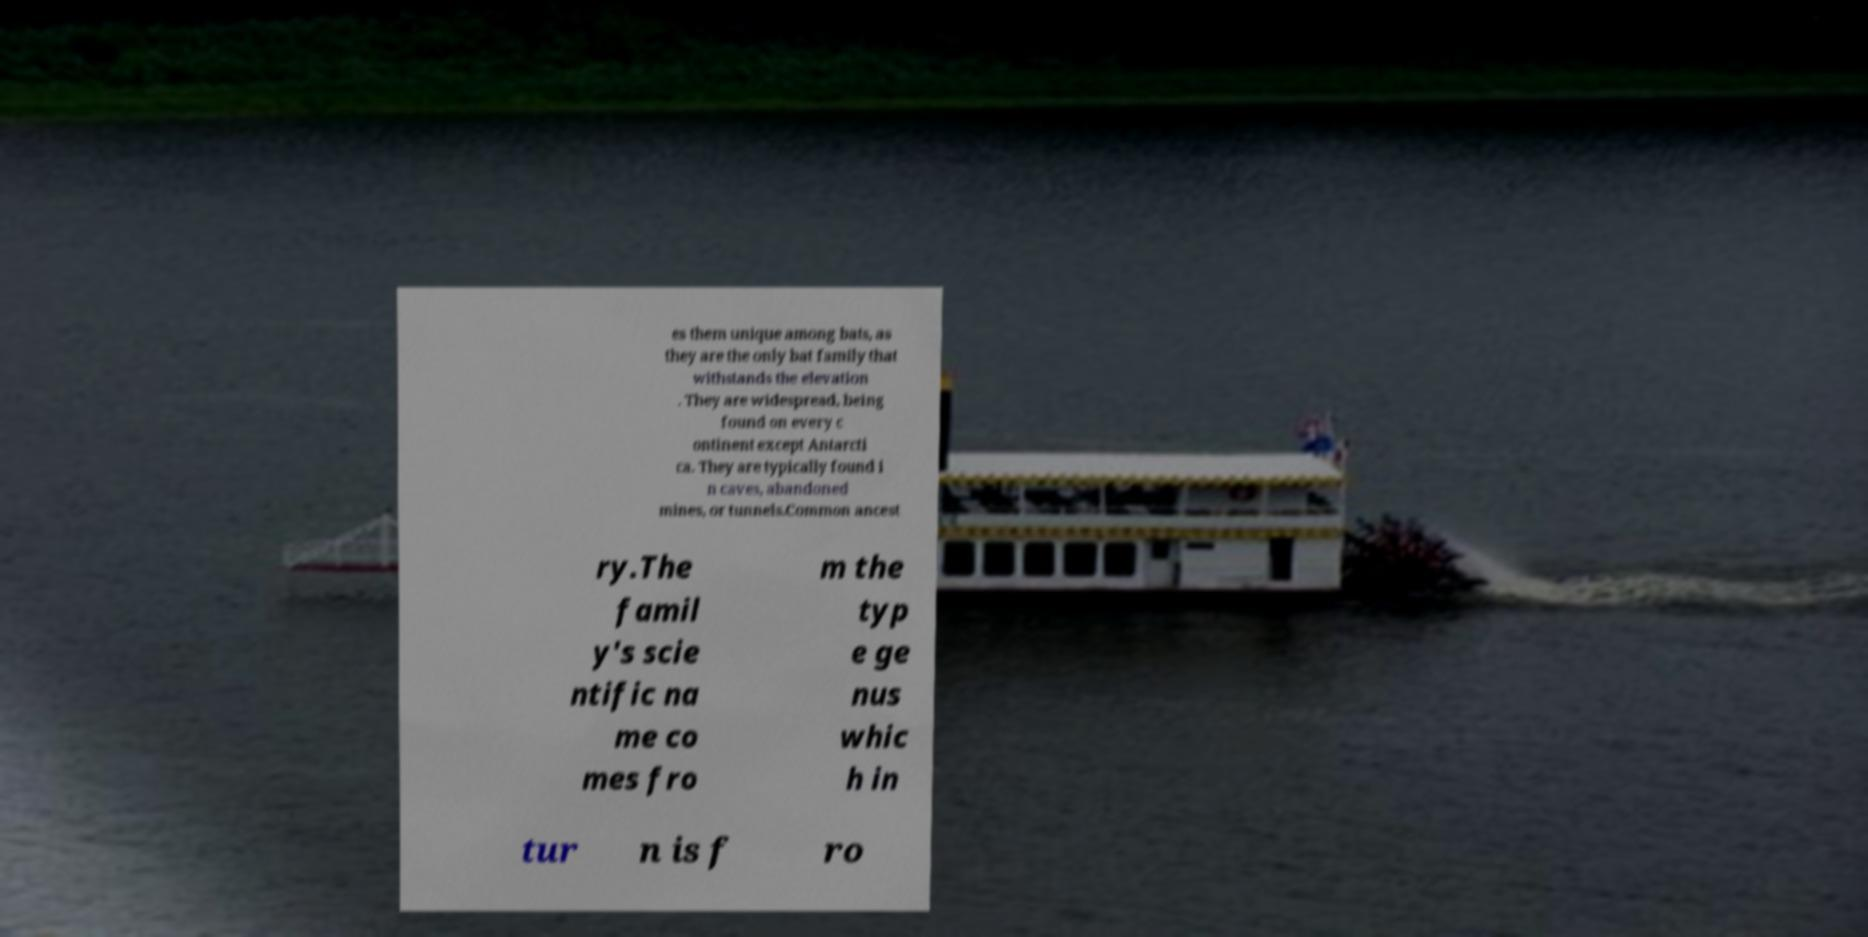I need the written content from this picture converted into text. Can you do that? es them unique among bats, as they are the only bat family that withstands the elevation . They are widespread, being found on every c ontinent except Antarcti ca. They are typically found i n caves, abandoned mines, or tunnels.Common ancest ry.The famil y's scie ntific na me co mes fro m the typ e ge nus whic h in tur n is f ro 